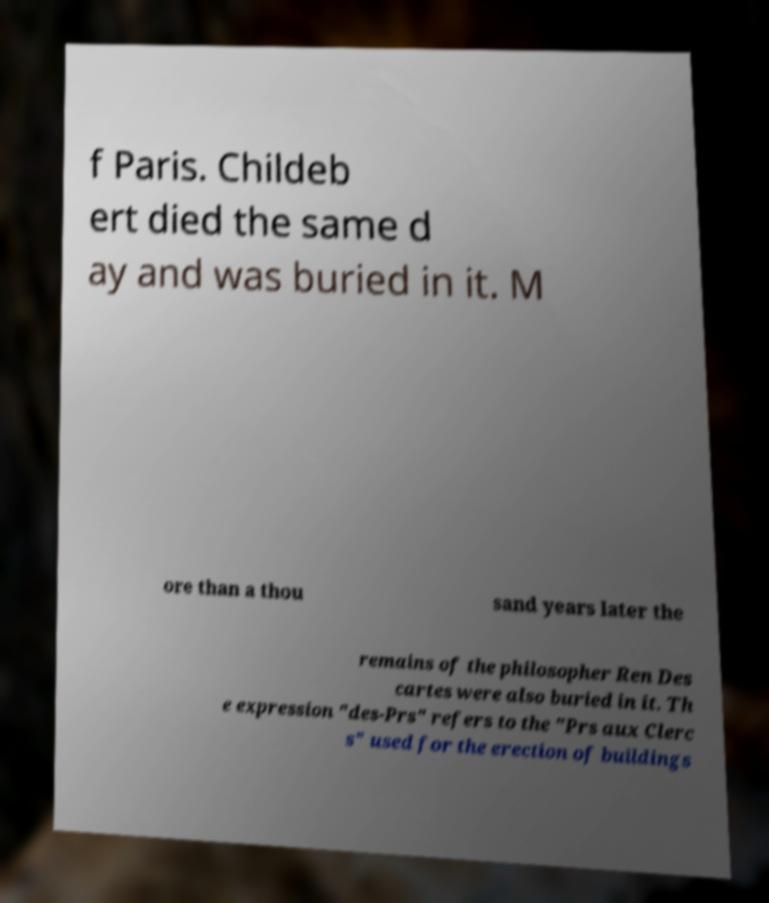Can you accurately transcribe the text from the provided image for me? f Paris. Childeb ert died the same d ay and was buried in it. M ore than a thou sand years later the remains of the philosopher Ren Des cartes were also buried in it. Th e expression "des-Prs" refers to the "Prs aux Clerc s" used for the erection of buildings 